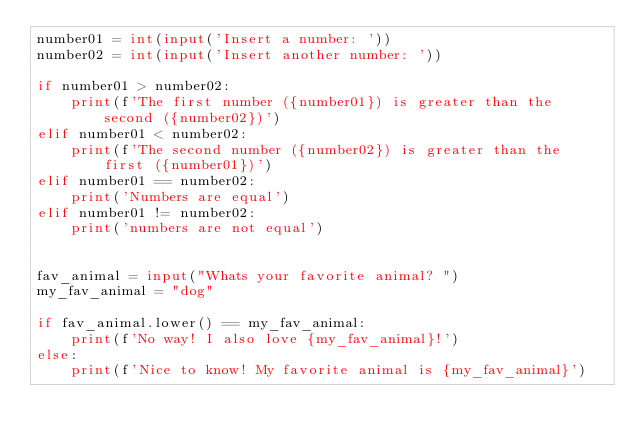<code> <loc_0><loc_0><loc_500><loc_500><_Python_>number01 = int(input('Insert a number: '))
number02 = int(input('Insert another number: '))

if number01 > number02:
    print(f'The first number ({number01}) is greater than the second ({number02})')
elif number01 < number02:
    print(f'The second number ({number02}) is greater than the first ({number01})')
elif number01 == number02:
    print('Numbers are equal')
elif number01 != number02:
    print('numbers are not equal')


fav_animal = input("Whats your favorite animal? ")
my_fav_animal = "dog"

if fav_animal.lower() == my_fav_animal:
    print(f'No way! I also love {my_fav_animal}!')
else:
    print(f'Nice to know! My favorite animal is {my_fav_animal}')
</code> 